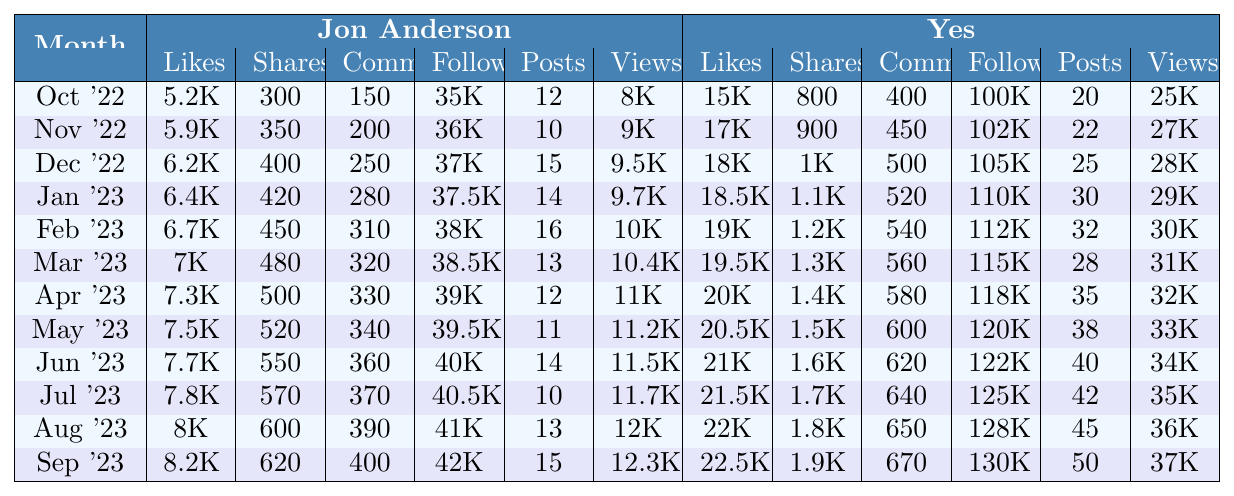What were Jon Anderson's likes in January 2023? In the table, we find that in January 2023, Jon Anderson received 6,400 likes.
Answer: 6,400 What was the total number of video views for Yes in February and March 2023 combined? In February 2023, Yes had 30,000 views, and in March 2023, they had 31,000 views. Adding these gives 30,000 + 31,000 = 61,000 views.
Answer: 61,000 Did Jon Anderson gain followers each month during the year? By checking the follower counts month by month, we see that Jon Anderson's followers consistently increased from 35,000 in October 2022 to 42,000 in September 2023.
Answer: Yes Which month saw the highest number of likes for Yes? Scanning through the likes for Yes, September 2023 stands out with 22,500 likes, which is higher than any other month.
Answer: September 2023 What is the average number of likes for Jon Anderson over the last year? To find the average, we sum all of Jon Anderson's likes from each month (5,200 + 5,900 + 6,200 + 6,400 + 6,700 + 7,000 + 7,300 + 7,500 + 7,700 + 7,800 + 8,000 + 8,200) = 81,900, then divide by 12 months, which gives approximately 6,825.
Answer: 6,825 In which month did Jon Anderson have more posts than Yes? Looking at the posts, Jon Anderson had 14 posts in January 2023 while Yes had 30 posts. No month meets this criteria, therefore Jon never had more posts than Yes in this period.
Answer: None What was the percentage increase in followers for Yes from October 2022 to September 2023? Yes started with 100,000 followers in October 2022 and ended with 130,000 in September 2023. The increase is 130,000 - 100,000 = 30,000. The percentage increase is (30,000 / 100,000) * 100 = 30%.
Answer: 30% Was there a month when Jon Anderson had fewer shares than Yes? Checking the shares for each month reveals Jon had fewer shares than Yes in all months compared to Yes's increasing shares.
Answer: Yes How many comments did Yes receive in August 2023? In August 2023, the number of comments for Yes was 650, as stated in that month's row.
Answer: 650 In which month did Jon Anderson achieve the highest number of video views? Looking through the video views, Jon Anderson achieved the highest number in June 2023 with 11,500 views.
Answer: June 2023 What is the difference in comments between Jon Anderson and Yes for July 2023? In July 2023, Jon Anderson had 370 comments while Yes had 640 comments. The difference is 640 - 370 = 270.
Answer: 270 